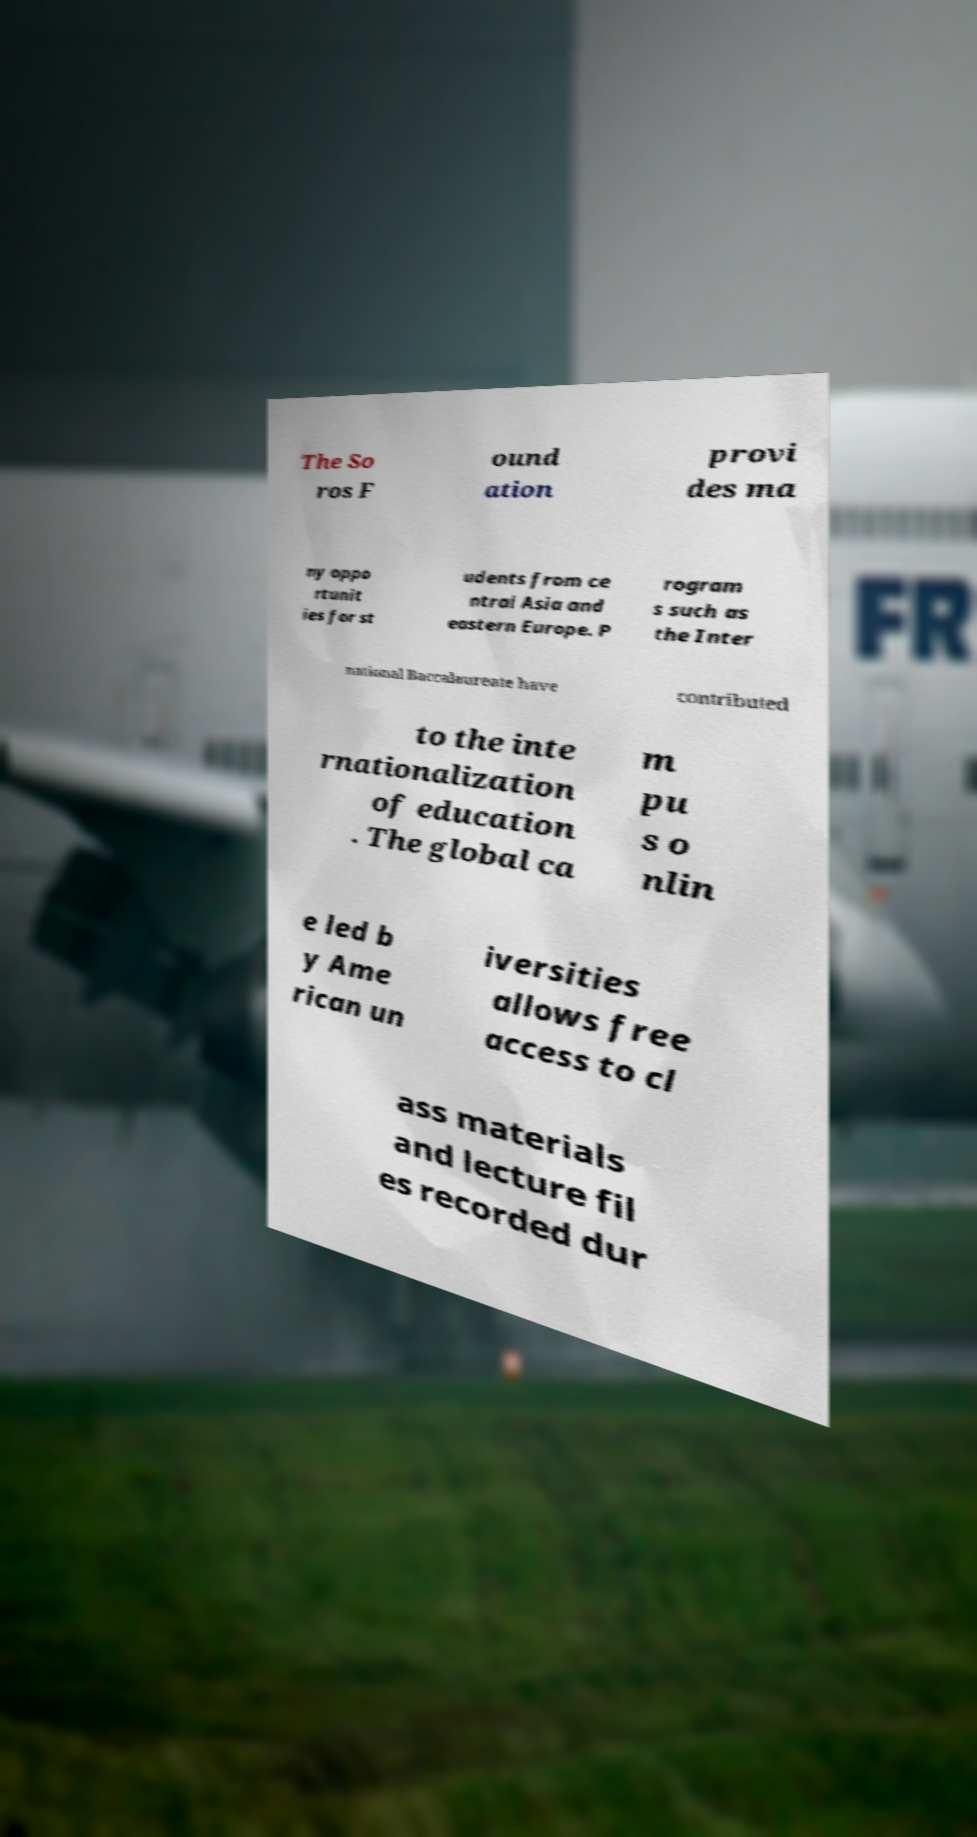For documentation purposes, I need the text within this image transcribed. Could you provide that? The So ros F ound ation provi des ma ny oppo rtunit ies for st udents from ce ntral Asia and eastern Europe. P rogram s such as the Inter national Baccalaureate have contributed to the inte rnationalization of education . The global ca m pu s o nlin e led b y Ame rican un iversities allows free access to cl ass materials and lecture fil es recorded dur 